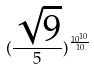<formula> <loc_0><loc_0><loc_500><loc_500>( \frac { \sqrt { 9 } } { 5 } ) ^ { \frac { 1 0 ^ { 1 0 } } { 1 0 } }</formula> 